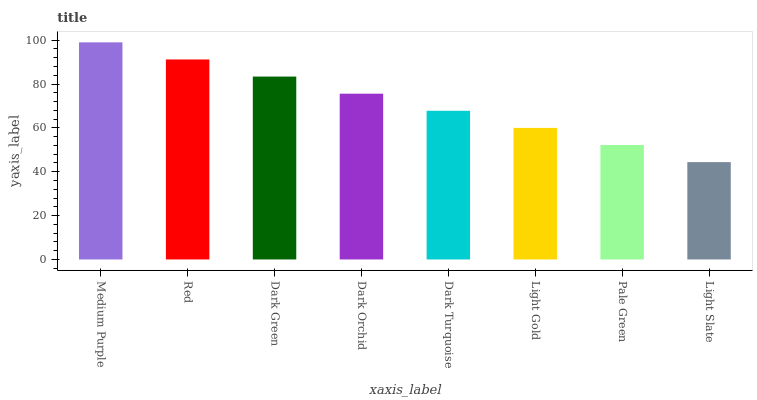Is Red the minimum?
Answer yes or no. No. Is Red the maximum?
Answer yes or no. No. Is Medium Purple greater than Red?
Answer yes or no. Yes. Is Red less than Medium Purple?
Answer yes or no. Yes. Is Red greater than Medium Purple?
Answer yes or no. No. Is Medium Purple less than Red?
Answer yes or no. No. Is Dark Orchid the high median?
Answer yes or no. Yes. Is Dark Turquoise the low median?
Answer yes or no. Yes. Is Light Slate the high median?
Answer yes or no. No. Is Dark Green the low median?
Answer yes or no. No. 